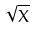<formula> <loc_0><loc_0><loc_500><loc_500>\sqrt { X }</formula> 